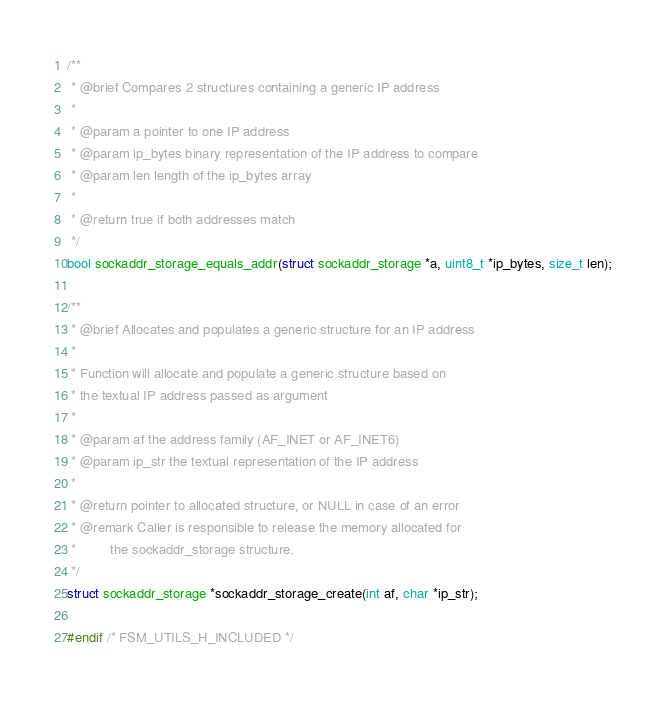<code> <loc_0><loc_0><loc_500><loc_500><_C_>
/**
 * @brief Compares 2 structures containing a generic IP address
 *
 * @param a pointer to one IP address
 * @param ip_bytes binary representation of the IP address to compare
 * @param len length of the ip_bytes array
 *
 * @return true if both addresses match
 */
bool sockaddr_storage_equals_addr(struct sockaddr_storage *a, uint8_t *ip_bytes, size_t len);

/**
 * @brief Allocates and populates a generic structure for an IP address
 *
 * Function will allocate and populate a generic structure based on
 * the textual IP address passed as argument
 *
 * @param af the address family (AF_INET or AF_INET6)
 * @param ip_str the textual representation of the IP address
 *
 * @return pointer to allocated structure, or NULL in case of an error
 * @remark Caller is responsible to release the memory allocated for
 *         the sockaddr_storage structure.
 */
struct sockaddr_storage *sockaddr_storage_create(int af, char *ip_str);

#endif /* FSM_UTILS_H_INCLUDED */
</code> 